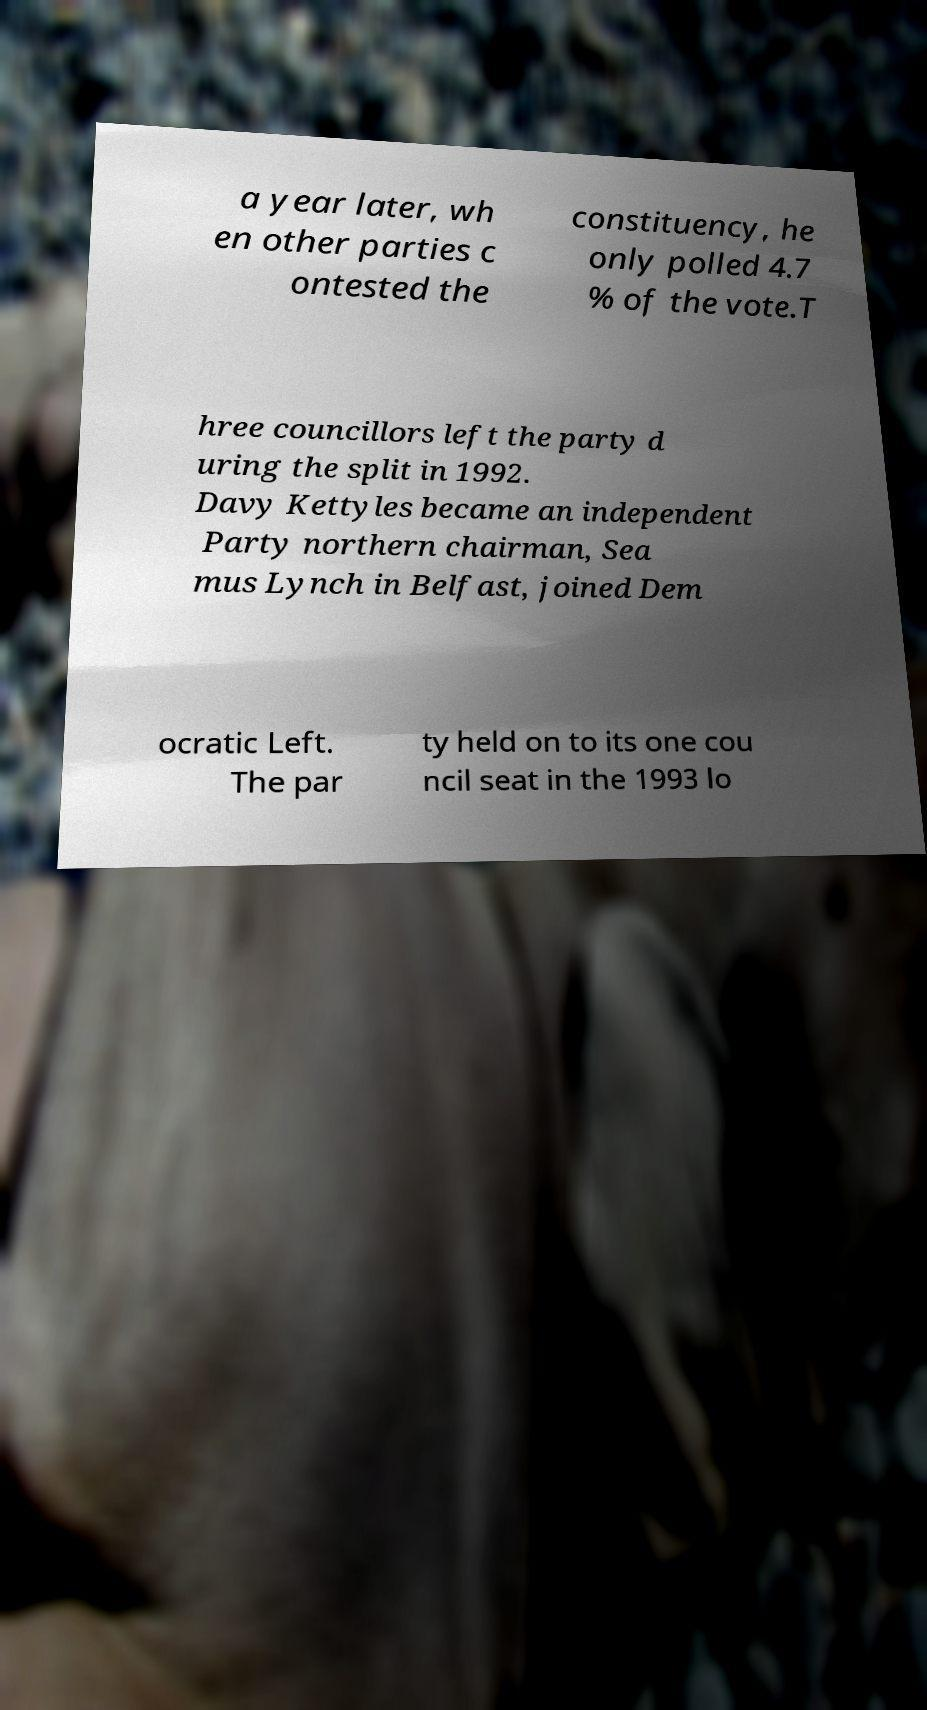For documentation purposes, I need the text within this image transcribed. Could you provide that? a year later, wh en other parties c ontested the constituency, he only polled 4.7 % of the vote.T hree councillors left the party d uring the split in 1992. Davy Kettyles became an independent Party northern chairman, Sea mus Lynch in Belfast, joined Dem ocratic Left. The par ty held on to its one cou ncil seat in the 1993 lo 